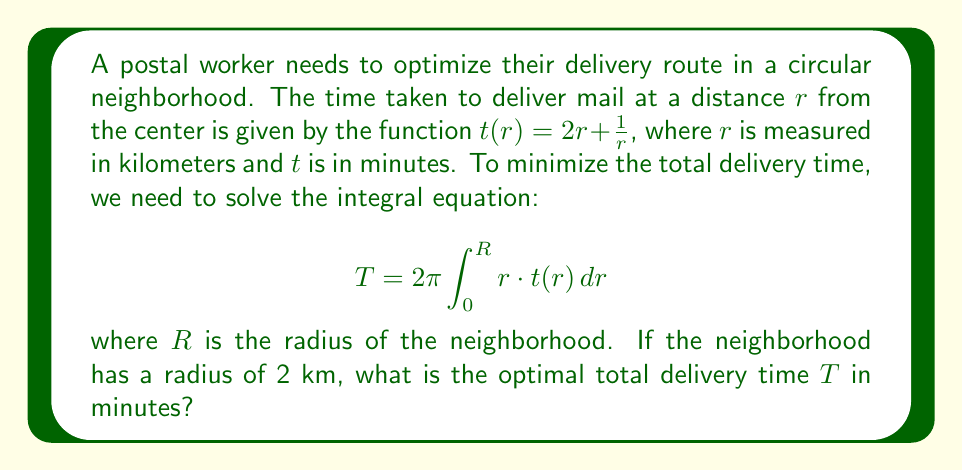Solve this math problem. Let's solve this problem step by step:

1) First, we substitute the given function $t(r) = 2r + \frac{1}{r}$ into the integral equation:

   $$T = 2\pi \int_0^R r \cdot (2r + \frac{1}{r}) \, dr = 2\pi \int_0^R (2r^2 + 1) \, dr$$

2) Now, we integrate this function from 0 to R:

   $$T = 2\pi \left[\frac{2r^3}{3} + r\right]_0^R = 2\pi \left(\frac{2R^3}{3} + R\right)$$

3) We're given that the radius of the neighborhood $R = 2$ km. Let's substitute this:

   $$T = 2\pi \left(\frac{2(2^3)}{3} + 2\right) = 2\pi \left(\frac{16}{3} + 2\right) = 2\pi \left(\frac{22}{3}\right)$$

4) Now, let's calculate this value:

   $$T = 2 \cdot 3.14159 \cdot \frac{22}{3} \approx 45.87 \text{ minutes}$$

Therefore, the optimal total delivery time is approximately 45.87 minutes.
Answer: 45.87 minutes 